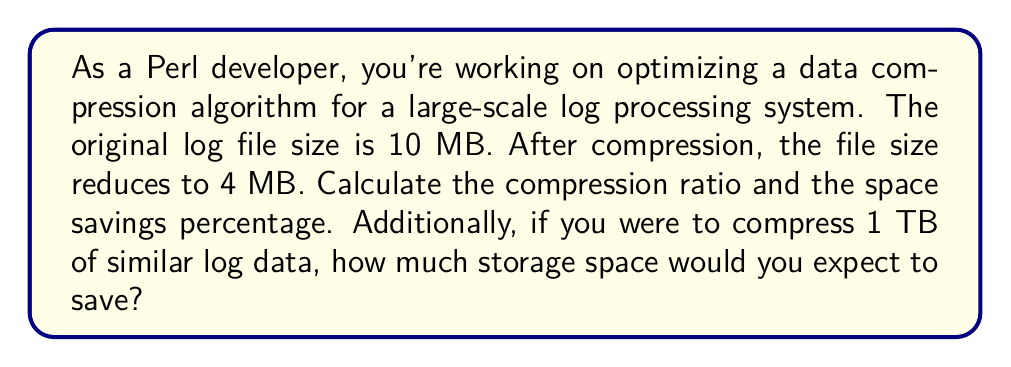Provide a solution to this math problem. To solve this problem, we need to understand two key concepts: compression ratio and space savings percentage.

1. Compression Ratio:
The compression ratio is defined as:

$$ \text{Compression Ratio} = \frac{\text{Uncompressed Size}}{\text{Compressed Size}} $$

In this case:
$$ \text{Compression Ratio} = \frac{10 \text{ MB}}{4 \text{ MB}} = 2.5 $$

2. Space Savings Percentage:
The space savings percentage is calculated as:

$$ \text{Space Savings} = \left(1 - \frac{\text{Compressed Size}}{\text{Uncompressed Size}}\right) \times 100\% $$

Plugging in our values:
$$ \text{Space Savings} = \left(1 - \frac{4 \text{ MB}}{10 \text{ MB}}\right) \times 100\% = 60\% $$

3. Estimating savings for 1 TB of data:
First, let's convert 1 TB to MB:
$$ 1 \text{ TB} = 1,000,000 \text{ MB} $$

Now, we can use the space savings percentage to calculate the expected saved space:
$$ \text{Saved Space} = 1,000,000 \text{ MB} \times 60\% = 600,000 \text{ MB} = 600 \text{ GB} $$
Answer: Compression Ratio: 2.5
Space Savings Percentage: 60%
Expected storage space saved for 1 TB of data: 600 GB 